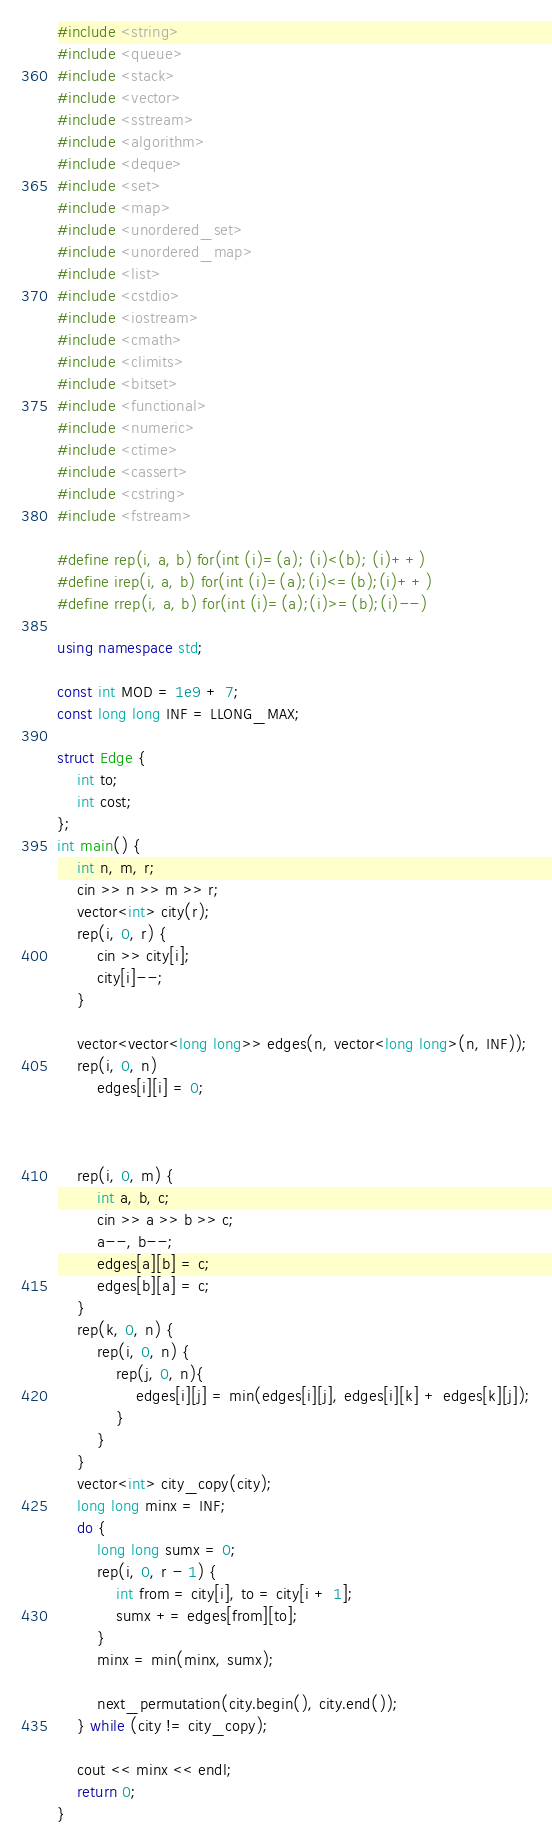<code> <loc_0><loc_0><loc_500><loc_500><_C++_>#include <string>
#include <queue>
#include <stack>
#include <vector>
#include <sstream>
#include <algorithm>
#include <deque>
#include <set>
#include <map>
#include <unordered_set>
#include <unordered_map>
#include <list>
#include <cstdio>
#include <iostream>
#include <cmath>
#include <climits>
#include <bitset>
#include <functional>
#include <numeric>
#include <ctime>
#include <cassert>
#include <cstring>
#include <fstream>

#define rep(i, a, b) for(int (i)=(a); (i)<(b); (i)++)
#define irep(i, a, b) for(int (i)=(a);(i)<=(b);(i)++)
#define rrep(i, a, b) for(int (i)=(a);(i)>=(b);(i)--)

using namespace std;

const int MOD = 1e9 + 7;
const long long INF = LLONG_MAX;

struct Edge {
    int to;
    int cost;
};
int main() {
    int n, m, r;
    cin >> n >> m >> r;
    vector<int> city(r);
    rep(i, 0, r) {
        cin >> city[i];
        city[i]--;
    }

    vector<vector<long long>> edges(n, vector<long long>(n, INF));
    rep(i, 0, n)
        edges[i][i] = 0;


    
    rep(i, 0, m) {
        int a, b, c;
        cin >> a >> b >> c;
        a--, b--;
        edges[a][b] = c;
        edges[b][a] = c;
    }
    rep(k, 0, n) {
        rep(i, 0, n) {
            rep(j, 0, n){
                edges[i][j] = min(edges[i][j], edges[i][k] + edges[k][j]);
            }
        }
    }
    vector<int> city_copy(city);
    long long minx = INF;
    do {
        long long sumx = 0;
        rep(i, 0, r - 1) {
            int from = city[i], to = city[i + 1];
            sumx += edges[from][to];
        }
        minx = min(minx, sumx);
        
        next_permutation(city.begin(), city.end());
    } while (city != city_copy);

    cout << minx << endl;
    return 0;
}</code> 